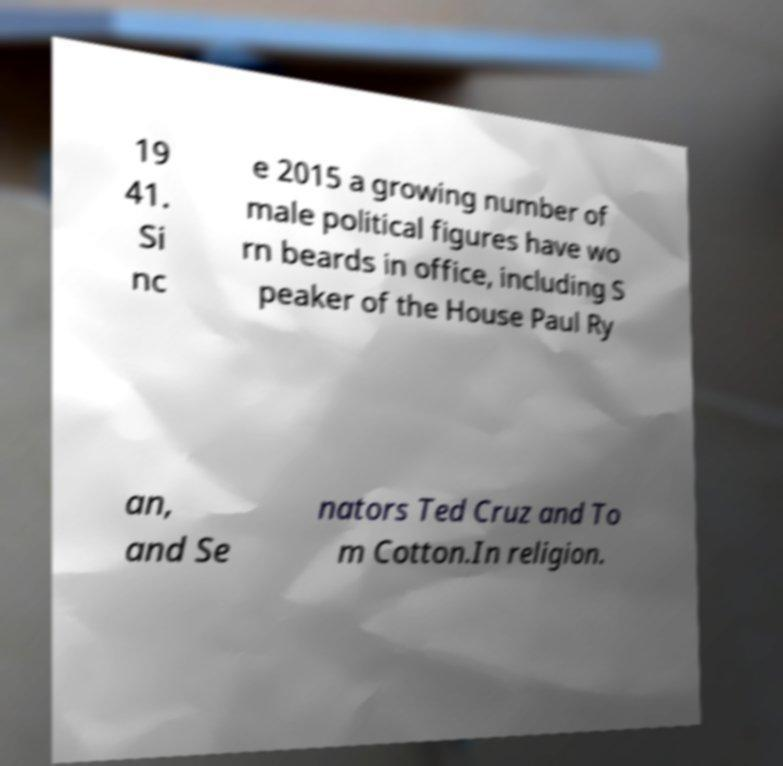Please read and relay the text visible in this image. What does it say? 19 41. Si nc e 2015 a growing number of male political figures have wo rn beards in office, including S peaker of the House Paul Ry an, and Se nators Ted Cruz and To m Cotton.In religion. 